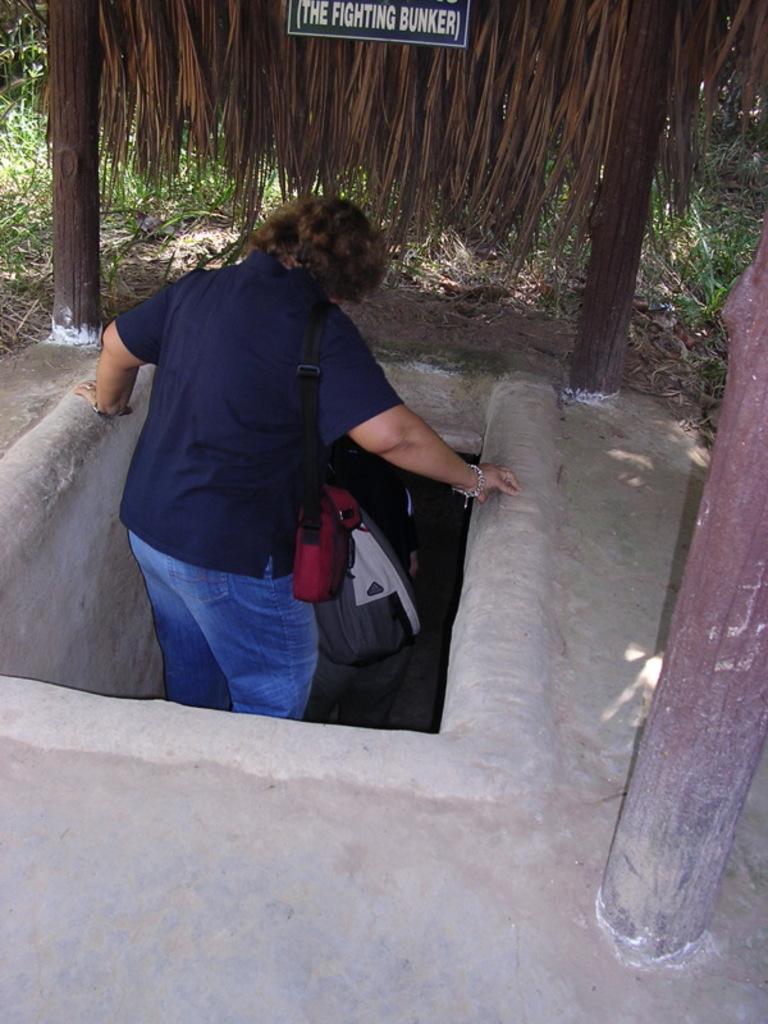Describe this image in one or two sentences. This picture is clicked outside. In the center there is a person wearing blue color t-shirt, sling bag and standing. On the right corner there is a bamboo. In the background we can see the green grass, bamboo and leaves and some other items. 